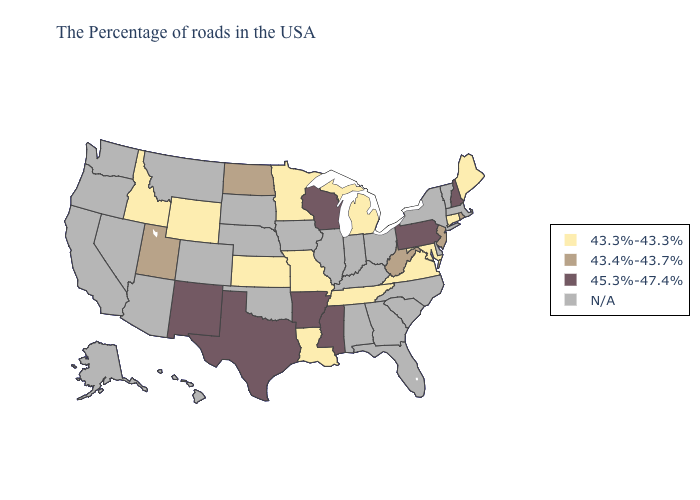Name the states that have a value in the range 43.4%-43.7%?
Keep it brief. Rhode Island, New Jersey, West Virginia, North Dakota, Utah. Which states have the lowest value in the USA?
Be succinct. Maine, Connecticut, Maryland, Virginia, Michigan, Tennessee, Louisiana, Missouri, Minnesota, Kansas, Wyoming, Idaho. What is the value of Arizona?
Write a very short answer. N/A. What is the lowest value in states that border Wisconsin?
Write a very short answer. 43.3%-43.3%. Does West Virginia have the lowest value in the USA?
Write a very short answer. No. What is the highest value in the USA?
Quick response, please. 45.3%-47.4%. Does the map have missing data?
Answer briefly. Yes. What is the value of Alabama?
Be succinct. N/A. Among the states that border Virginia , does Tennessee have the lowest value?
Concise answer only. Yes. Name the states that have a value in the range 43.3%-43.3%?
Keep it brief. Maine, Connecticut, Maryland, Virginia, Michigan, Tennessee, Louisiana, Missouri, Minnesota, Kansas, Wyoming, Idaho. What is the value of Utah?
Keep it brief. 43.4%-43.7%. 